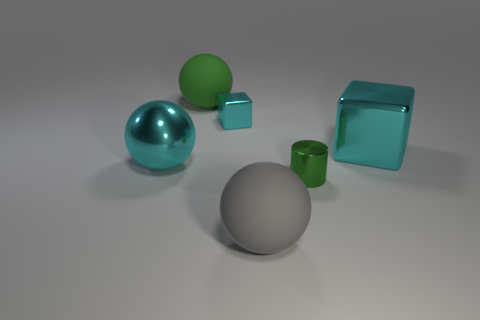Is the green metal object the same shape as the large gray object?
Keep it short and to the point. No. There is another shiny object that is the same shape as the big gray object; what is its color?
Your answer should be compact. Cyan. Are there more metal things that are right of the big green matte thing than big rubber spheres?
Provide a succinct answer. Yes. There is a big rubber object that is in front of the green matte sphere; what color is it?
Your answer should be compact. Gray. Does the cyan sphere have the same size as the gray ball?
Your answer should be compact. Yes. The green metal object has what size?
Offer a very short reply. Small. What shape is the rubber thing that is the same color as the small cylinder?
Offer a very short reply. Sphere. Is the number of brown metal cubes greater than the number of big gray matte spheres?
Keep it short and to the point. No. What is the color of the tiny object on the left side of the small thing that is in front of the big cyan metallic object left of the small green shiny cylinder?
Provide a short and direct response. Cyan. There is a object on the left side of the green matte object; does it have the same shape as the gray matte object?
Offer a very short reply. Yes. 